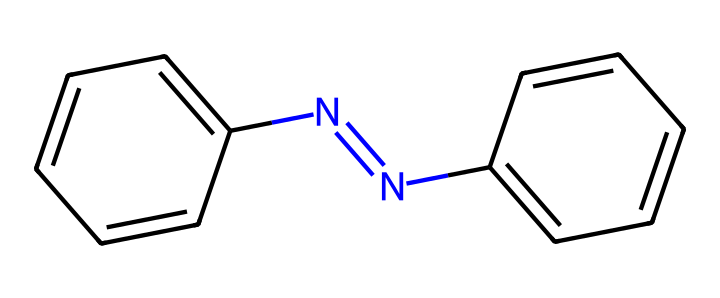What is the molecular formula of azobenzene? To determine the molecular formula from its SMILES representation, we analyze the structure. The molecule has two benzene rings (C6H5) connected by a N=N double bond (2 Nitrogens). Counting all carbons and hydrogens, we find a total of 12 carbons, 10 hydrogens, and 2 nitrogens. Thus, the molecular formula is C12H10N2.
Answer: C12H10N2 How many nitrogen atoms are in azobenzene? By examining the SMILES representation, we see there are two nitrogen atoms present in the N=N part of the molecule. Therefore, the count is straightforward.
Answer: 2 What type of functional group is present in azobenzene? The key feature in the structure is the N=N double bond, which identifies it as a diazo group. This specific functional group defines the molecule's photoswitchable properties.
Answer: diazo group How many aromatic rings are in azobenzene? Analyzing the structure reveals two benzene rings connected via the azobenzene bridge. Each benzene contributes to the aromaticity of the molecule. Therefore, the total is two aromatic rings.
Answer: 2 What makes azobenzene a photoswitchable molecule? Azobenzene's ability to switch between trans and cis forms upon exposure to light allows it to change conformations. This is attributed to the N=N double bond, which can undergo isomerization.
Answer: N=N double bond Which of the atoms in azobenzene can potentially undergo reaction with electrophiles? The nitrogen atoms in the N=N bond can act as nucleophiles, making them sites for electrophilic attack. In a photoswitchable context, this is significant for the chemistry involved.
Answer: nitrogen atoms 